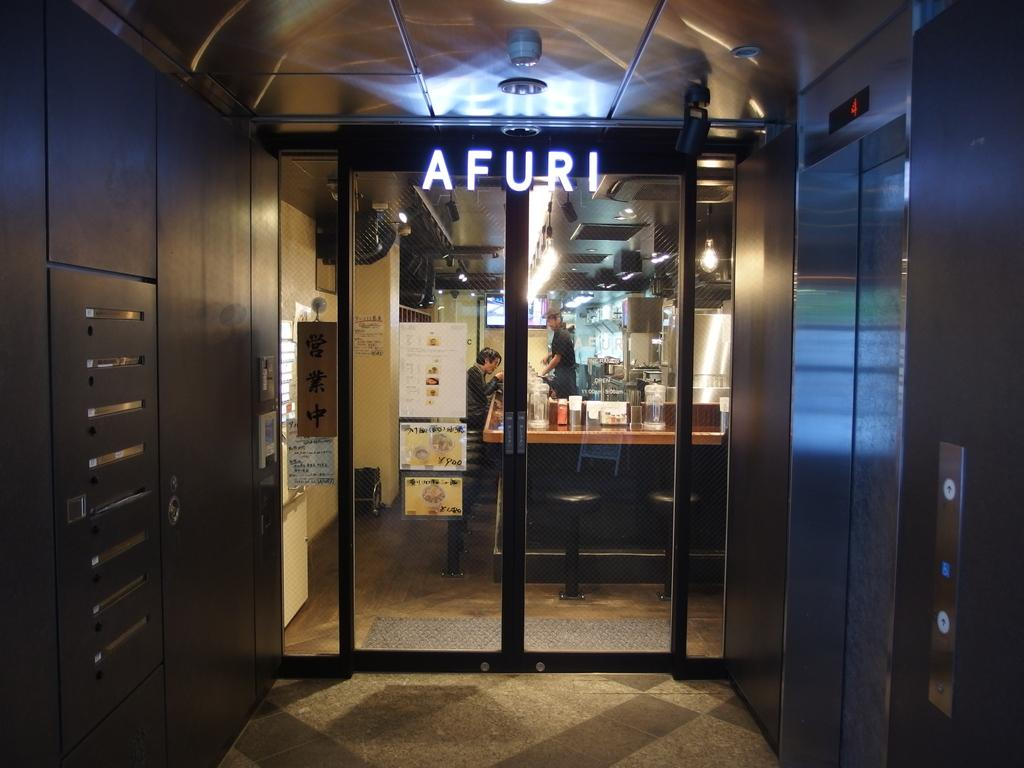<image>
Create a compact narrative representing the image presented. an entrance to a place that is called Afuri 